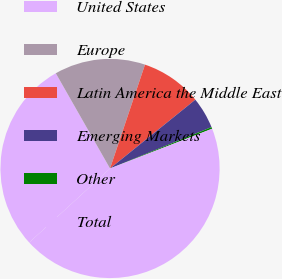<chart> <loc_0><loc_0><loc_500><loc_500><pie_chart><fcel>United States<fcel>Europe<fcel>Latin America the Middle East<fcel>Emerging Markets<fcel>Other<fcel>Total<nl><fcel>28.56%<fcel>13.41%<fcel>9.03%<fcel>4.64%<fcel>0.25%<fcel>44.11%<nl></chart> 